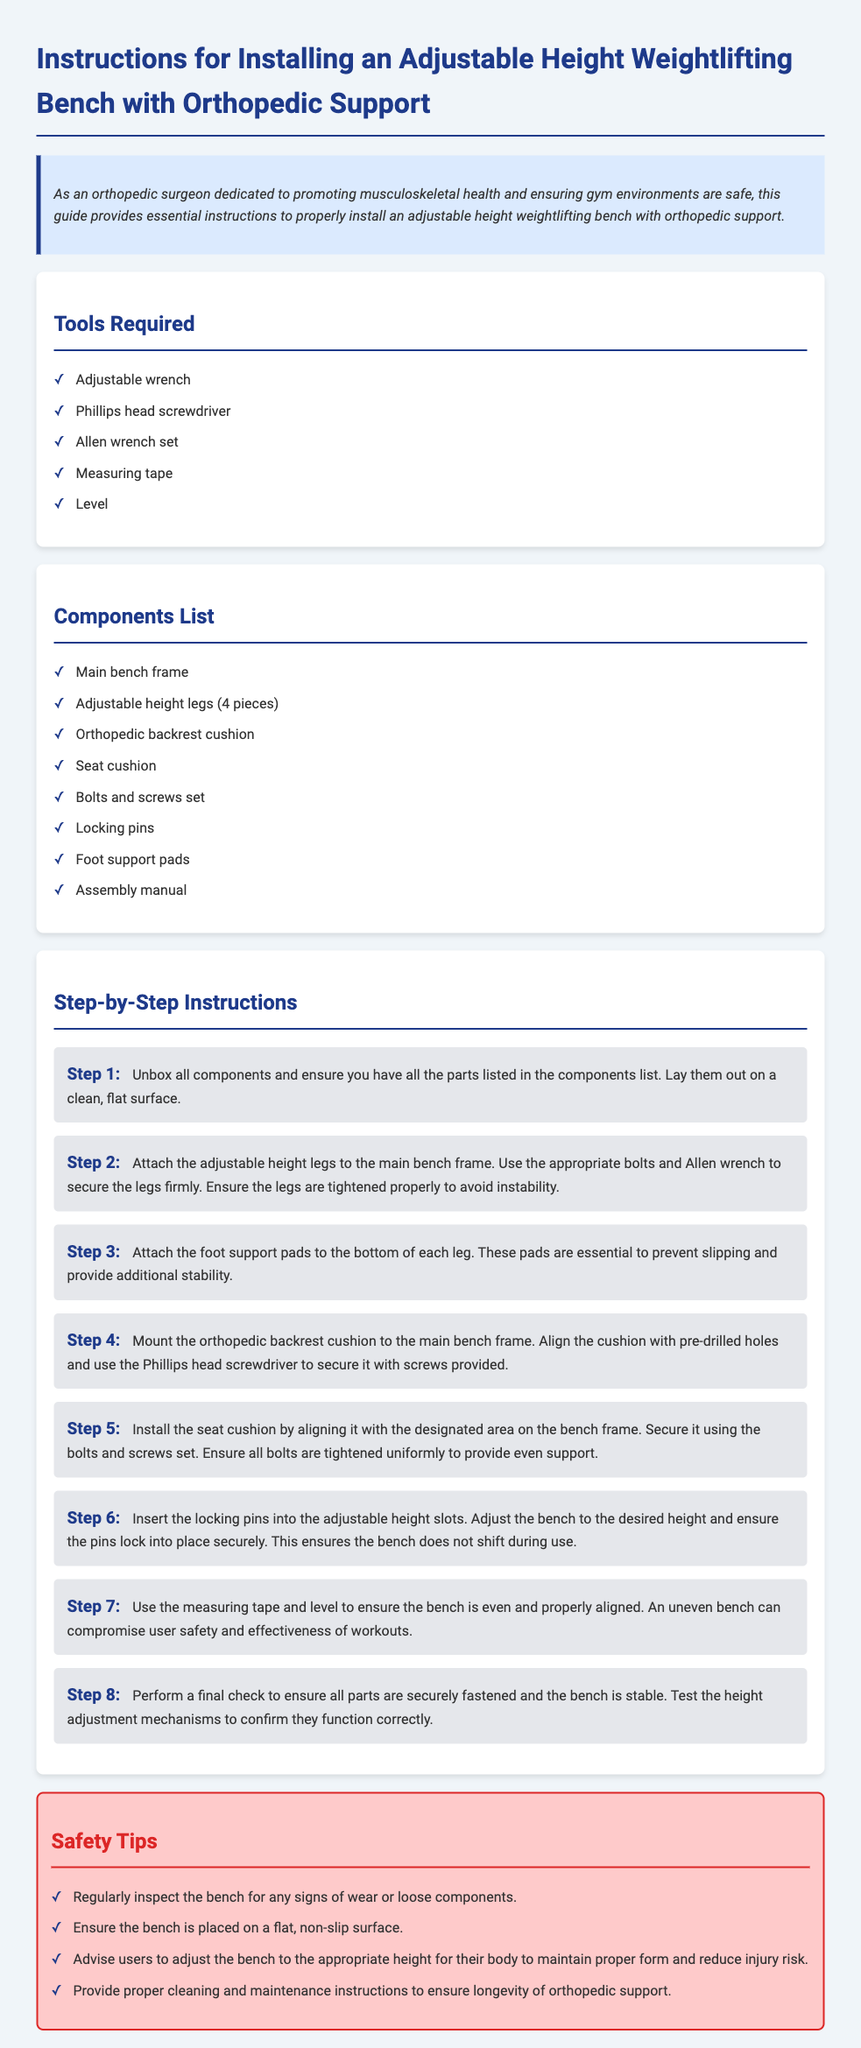What is the first step in assembling the bench? The first step is to unbox all components and ensure you have all the parts listed in the components list.
Answer: Unbox all components How many adjustable height legs are included? The components list states that there are 4 pieces of adjustable height legs.
Answer: 4 pieces What tool is needed to secure the orthopedic backrest cushion? The instructions specify using a Phillips head screwdriver to secure the cushion.
Answer: Phillips head screwdriver What is the purpose of the foot support pads? The foot support pads are essential to prevent slipping and provide additional stability.
Answer: Prevent slipping What should you use to ensure the bench is even? The document advises using a measuring tape and level to ensure the bench is even.
Answer: Measuring tape and level What type of surface should the bench be placed on? The safety tips recommend placing the bench on a flat, non-slip surface.
Answer: Flat, non-slip surface How should users adjust the bench height for their safety? Users are advised to adjust the bench to the appropriate height for their body to maintain proper form.
Answer: Appropriate height for their body What color is the background of the instructions document? The background color is light gray as indicated in the style section.
Answer: Light gray 